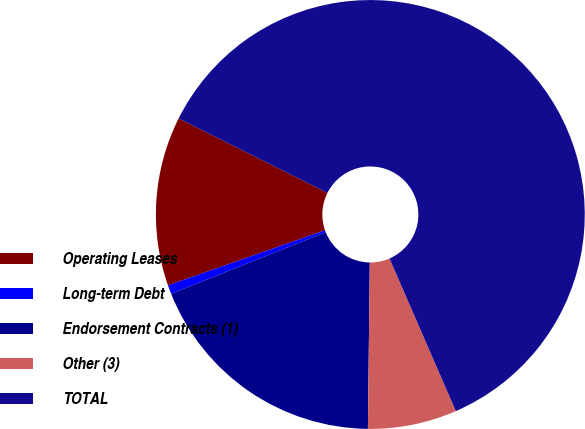Convert chart. <chart><loc_0><loc_0><loc_500><loc_500><pie_chart><fcel>Operating Leases<fcel>Long-term Debt<fcel>Endorsement Contracts (1)<fcel>Other (3)<fcel>TOTAL<nl><fcel>12.75%<fcel>0.67%<fcel>18.79%<fcel>6.71%<fcel>61.08%<nl></chart> 